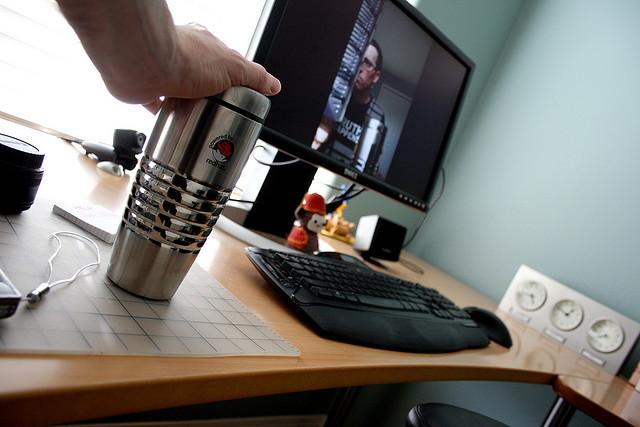What color is the cup?
Give a very brief answer. Silver. What color is the wall?
Give a very brief answer. Blue. What is the person touching?
Keep it brief. Mug. 